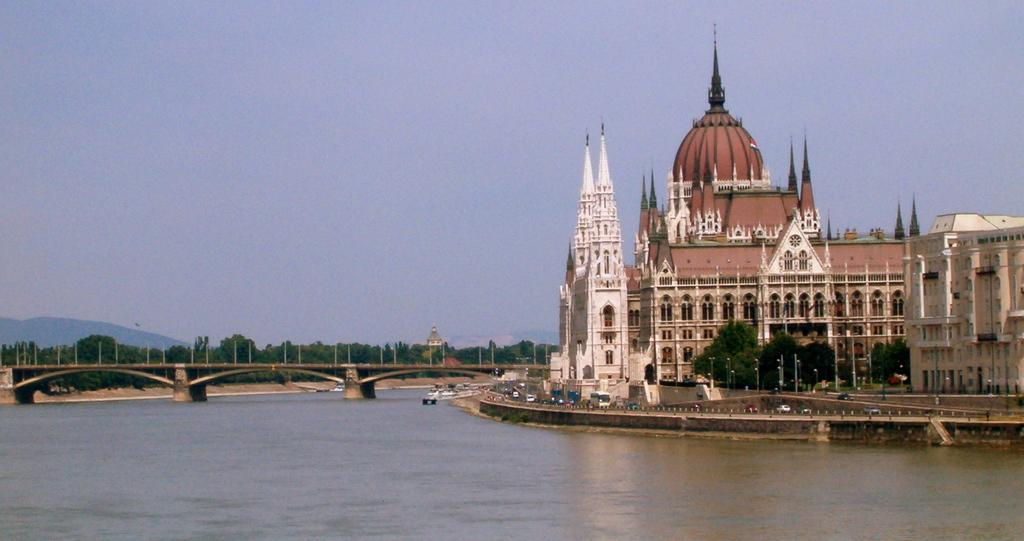What can be seen on the right side of the image? There are buildings and trees on the right side of the image. What is visible in the image besides the buildings and trees? There is water visible in the image. What structure is located on the left side of the image? There is a bridge on the left side of the image. What shape is the earthquake in the image? There is no earthquake present in the image. What type of square can be seen in the image? There is no square present in the image. 